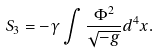<formula> <loc_0><loc_0><loc_500><loc_500>S _ { 3 } = - \gamma \int \frac { \Phi ^ { 2 } } { \sqrt { - g } } d ^ { 4 } x .</formula> 